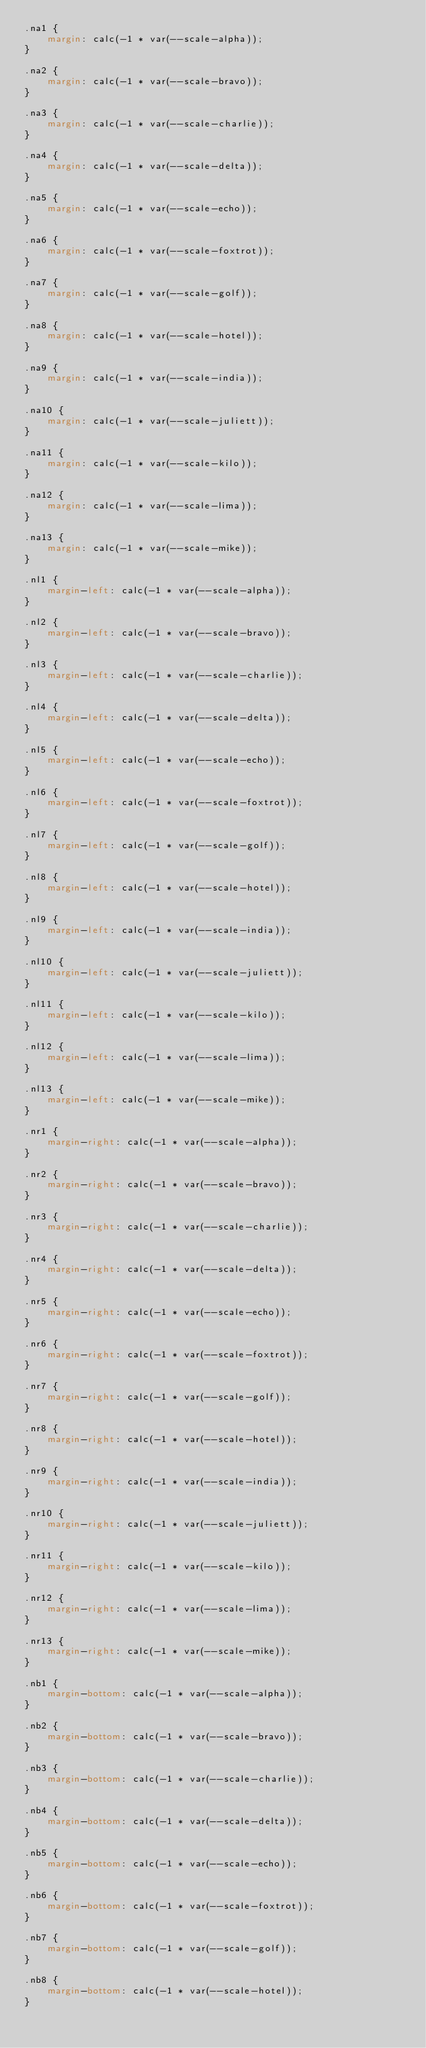Convert code to text. <code><loc_0><loc_0><loc_500><loc_500><_CSS_>.na1 {
    margin: calc(-1 * var(--scale-alpha));
}

.na2 {
    margin: calc(-1 * var(--scale-bravo));
}

.na3 {
    margin: calc(-1 * var(--scale-charlie));
}

.na4 {
    margin: calc(-1 * var(--scale-delta));
}

.na5 {
    margin: calc(-1 * var(--scale-echo));
}

.na6 {
    margin: calc(-1 * var(--scale-foxtrot));
}

.na7 {
    margin: calc(-1 * var(--scale-golf));
}

.na8 {
    margin: calc(-1 * var(--scale-hotel));
}

.na9 {
    margin: calc(-1 * var(--scale-india));
}

.na10 {
    margin: calc(-1 * var(--scale-juliett));
}

.na11 {
    margin: calc(-1 * var(--scale-kilo));
}

.na12 {
    margin: calc(-1 * var(--scale-lima));
}

.na13 {
    margin: calc(-1 * var(--scale-mike));
}

.nl1 {
    margin-left: calc(-1 * var(--scale-alpha));
}

.nl2 {
    margin-left: calc(-1 * var(--scale-bravo));
}

.nl3 {
    margin-left: calc(-1 * var(--scale-charlie));
}

.nl4 {
    margin-left: calc(-1 * var(--scale-delta));
}

.nl5 {
    margin-left: calc(-1 * var(--scale-echo));
}

.nl6 {
    margin-left: calc(-1 * var(--scale-foxtrot));
}

.nl7 {
    margin-left: calc(-1 * var(--scale-golf));
}

.nl8 {
    margin-left: calc(-1 * var(--scale-hotel));
}

.nl9 {
    margin-left: calc(-1 * var(--scale-india));
}

.nl10 {
    margin-left: calc(-1 * var(--scale-juliett));
}

.nl11 {
    margin-left: calc(-1 * var(--scale-kilo));
}

.nl12 {
    margin-left: calc(-1 * var(--scale-lima));
}

.nl13 {
    margin-left: calc(-1 * var(--scale-mike));
}

.nr1 {
    margin-right: calc(-1 * var(--scale-alpha));
}

.nr2 {
    margin-right: calc(-1 * var(--scale-bravo));
}

.nr3 {
    margin-right: calc(-1 * var(--scale-charlie));
}

.nr4 {
    margin-right: calc(-1 * var(--scale-delta));
}

.nr5 {
    margin-right: calc(-1 * var(--scale-echo));
}

.nr6 {
    margin-right: calc(-1 * var(--scale-foxtrot));
}

.nr7 {
    margin-right: calc(-1 * var(--scale-golf));
}

.nr8 {
    margin-right: calc(-1 * var(--scale-hotel));
}

.nr9 {
    margin-right: calc(-1 * var(--scale-india));
}

.nr10 {
    margin-right: calc(-1 * var(--scale-juliett));
}

.nr11 {
    margin-right: calc(-1 * var(--scale-kilo));
}

.nr12 {
    margin-right: calc(-1 * var(--scale-lima));
}

.nr13 {
    margin-right: calc(-1 * var(--scale-mike));
}

.nb1 {
    margin-bottom: calc(-1 * var(--scale-alpha));
}

.nb2 {
    margin-bottom: calc(-1 * var(--scale-bravo));
}

.nb3 {
    margin-bottom: calc(-1 * var(--scale-charlie));
}

.nb4 {
    margin-bottom: calc(-1 * var(--scale-delta));
}

.nb5 {
    margin-bottom: calc(-1 * var(--scale-echo));
}

.nb6 {
    margin-bottom: calc(-1 * var(--scale-foxtrot));
}

.nb7 {
    margin-bottom: calc(-1 * var(--scale-golf));
}

.nb8 {
    margin-bottom: calc(-1 * var(--scale-hotel));
}
</code> 